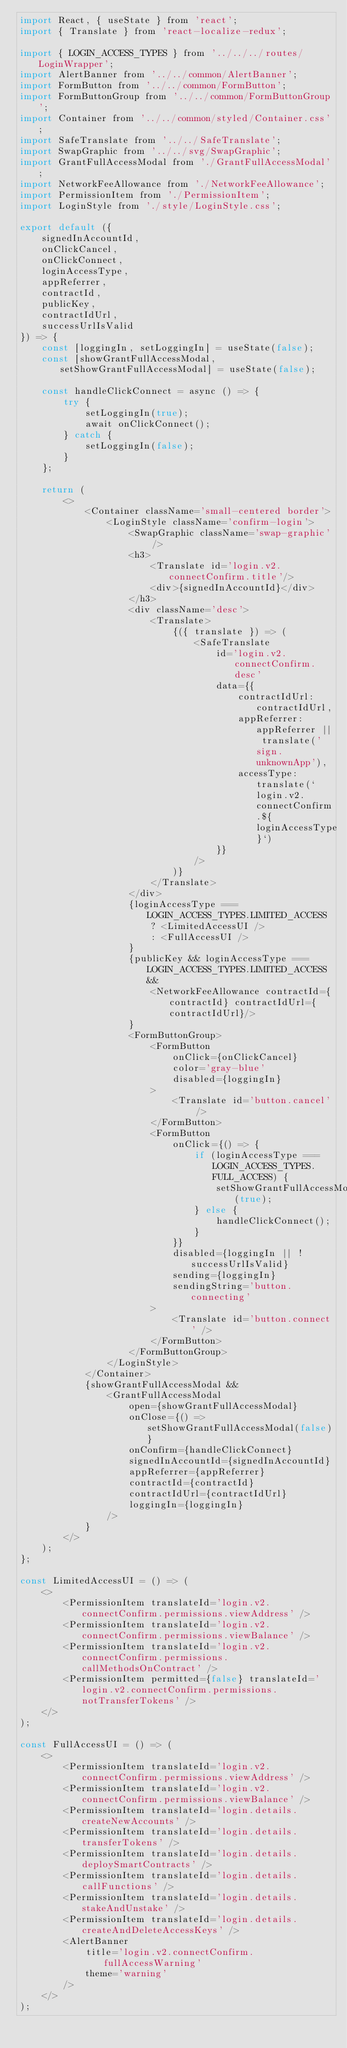<code> <loc_0><loc_0><loc_500><loc_500><_JavaScript_>import React, { useState } from 'react';
import { Translate } from 'react-localize-redux';

import { LOGIN_ACCESS_TYPES } from '../../../routes/LoginWrapper';
import AlertBanner from '../../common/AlertBanner';
import FormButton from '../../common/FormButton';
import FormButtonGroup from '../../common/FormButtonGroup';
import Container from '../../common/styled/Container.css';
import SafeTranslate from '../../SafeTranslate';
import SwapGraphic from '../../svg/SwapGraphic';
import GrantFullAccessModal from './GrantFullAccessModal';
import NetworkFeeAllowance from './NetworkFeeAllowance';
import PermissionItem from './PermissionItem';
import LoginStyle from './style/LoginStyle.css';

export default ({
    signedInAccountId,
    onClickCancel,
    onClickConnect,
    loginAccessType,
    appReferrer,
    contractId,
    publicKey,
    contractIdUrl,
    successUrlIsValid
}) => {
    const [loggingIn, setLoggingIn] = useState(false);
    const [showGrantFullAccessModal, setShowGrantFullAccessModal] = useState(false);

    const handleClickConnect = async () => {
        try {
            setLoggingIn(true);
            await onClickConnect();
        } catch {
            setLoggingIn(false);
        }
    };

    return (
        <>
            <Container className='small-centered border'>
                <LoginStyle className='confirm-login'>
                    <SwapGraphic className='swap-graphic' />
                    <h3>
                        <Translate id='login.v2.connectConfirm.title'/>
                        <div>{signedInAccountId}</div>
                    </h3>
                    <div className='desc'>
                        <Translate>
                            {({ translate }) => (
                                <SafeTranslate
                                    id='login.v2.connectConfirm.desc'
                                    data={{
                                        contractIdUrl: contractIdUrl,
                                        appReferrer: appReferrer || translate('sign.unknownApp'),
                                        accessType: translate(`login.v2.connectConfirm.${loginAccessType}`)
                                    }}
                                />
                            )}
                        </Translate>
                    </div>
                    {loginAccessType === LOGIN_ACCESS_TYPES.LIMITED_ACCESS
                        ? <LimitedAccessUI />
                        : <FullAccessUI />
                    }
                    {publicKey && loginAccessType === LOGIN_ACCESS_TYPES.LIMITED_ACCESS &&
                        <NetworkFeeAllowance contractId={contractId} contractIdUrl={contractIdUrl}/>
                    }
                    <FormButtonGroup>
                        <FormButton
                            onClick={onClickCancel}
                            color='gray-blue'
                            disabled={loggingIn}
                        >
                            <Translate id='button.cancel' />
                        </FormButton>
                        <FormButton
                            onClick={() => {
                                if (loginAccessType === LOGIN_ACCESS_TYPES.FULL_ACCESS) {
                                    setShowGrantFullAccessModal(true);
                                } else {
                                    handleClickConnect();
                                }
                            }}
                            disabled={loggingIn || !successUrlIsValid}
                            sending={loggingIn}
                            sendingString='button.connecting'
                        >
                            <Translate id='button.connect' />
                        </FormButton>
                    </FormButtonGroup>
                </LoginStyle>
            </Container>
            {showGrantFullAccessModal &&
                <GrantFullAccessModal
                    open={showGrantFullAccessModal}
                    onClose={() => setShowGrantFullAccessModal(false)}
                    onConfirm={handleClickConnect}
                    signedInAccountId={signedInAccountId}
                    appReferrer={appReferrer}
                    contractId={contractId}
                    contractIdUrl={contractIdUrl}
                    loggingIn={loggingIn}
                />
            }
        </>
    );
};

const LimitedAccessUI = () => (
    <>
        <PermissionItem translateId='login.v2.connectConfirm.permissions.viewAddress' />
        <PermissionItem translateId='login.v2.connectConfirm.permissions.viewBalance' />
        <PermissionItem translateId='login.v2.connectConfirm.permissions.callMethodsOnContract' />
        <PermissionItem permitted={false} translateId='login.v2.connectConfirm.permissions.notTransferTokens' />
    </>
);

const FullAccessUI = () => (
    <>
        <PermissionItem translateId='login.v2.connectConfirm.permissions.viewAddress' />
        <PermissionItem translateId='login.v2.connectConfirm.permissions.viewBalance' />
        <PermissionItem translateId='login.details.createNewAccounts' />
        <PermissionItem translateId='login.details.transferTokens' />
        <PermissionItem translateId='login.details.deploySmartContracts' />
        <PermissionItem translateId='login.details.callFunctions' />
        <PermissionItem translateId='login.details.stakeAndUnstake' />
        <PermissionItem translateId='login.details.createAndDeleteAccessKeys' />
        <AlertBanner
            title='login.v2.connectConfirm.fullAccessWarning'
            theme='warning'
        />
    </>
);
</code> 